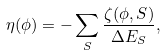<formula> <loc_0><loc_0><loc_500><loc_500>\eta ( \phi ) = - \sum _ { S } \frac { \zeta ( \phi , S ) } { \Delta E _ { S } } ,</formula> 